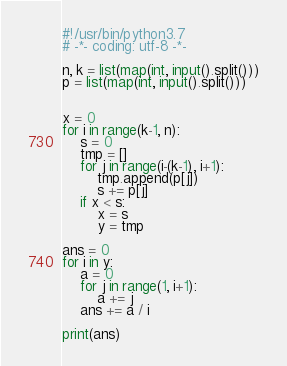<code> <loc_0><loc_0><loc_500><loc_500><_Python_>#!/usr/bin/python3.7
# -*- coding: utf-8 -*-

n, k = list(map(int, input().split()))
p = list(map(int, input().split()))


x = 0
for i in range(k-1, n):
	s = 0
	tmp = []
	for j in range(i-(k-1), i+1):
		tmp.append(p[j])
		s += p[j]
	if x < s:
		x = s
		y = tmp

ans = 0
for i in y:
	a = 0
	for j in range(1, i+1):
		a += j
	ans += a / i

print(ans)
</code> 